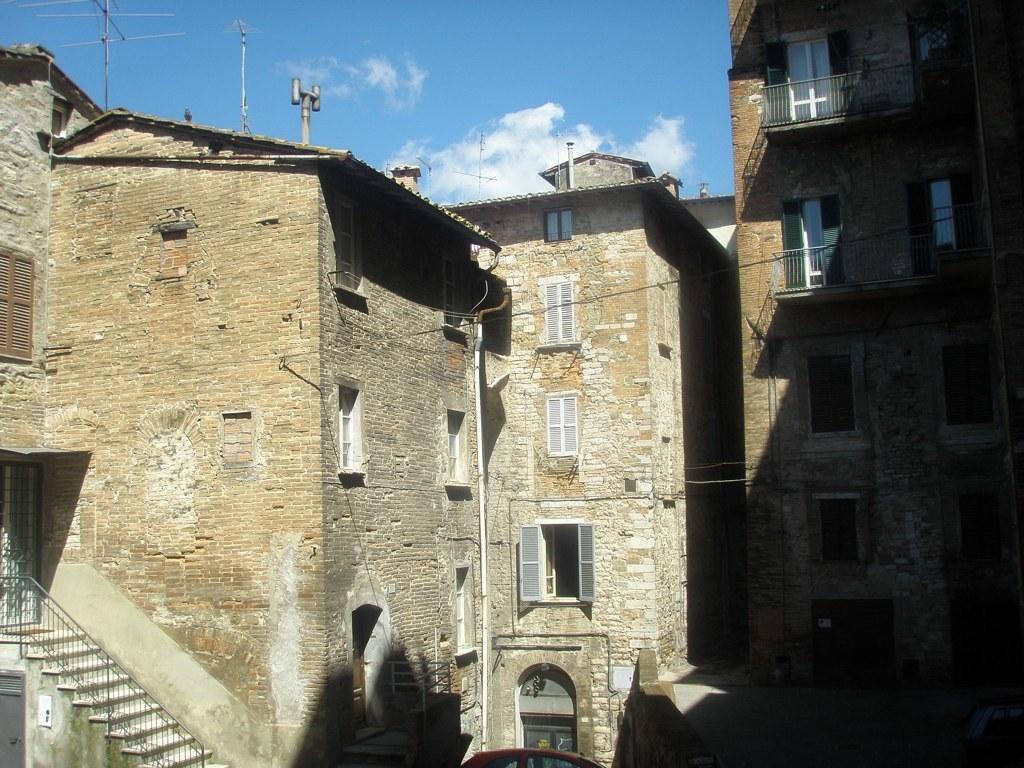Could you give a brief overview of what you see in this image? In this image there are buildings and on the top of the building there are antennas and on the left side there is a staircase and in the center there is a car which is red in colour. The sky is cloudy. 